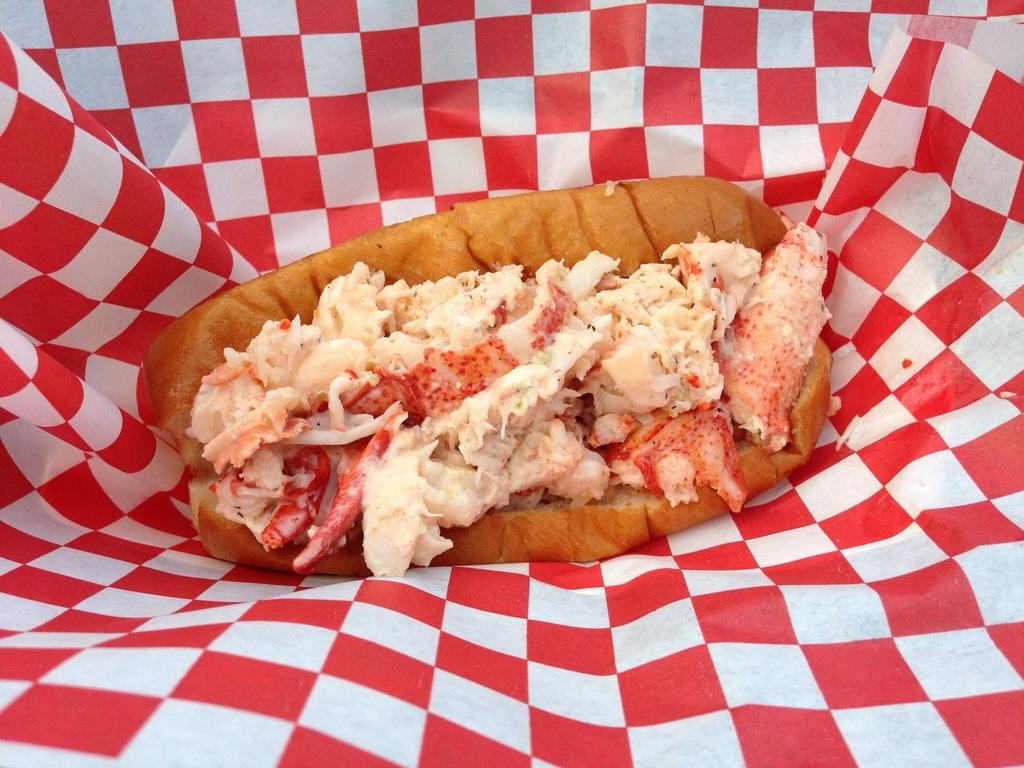What is the main subject of the image? There is a food item in the image. How is the food item wrapped? The food item is wrapped in a red and white paper. What type of chicken can be seen in the image? There is no chicken present in the image; it only features a food item wrapped in red and white paper. What is the needle used for in the image? There is no needle present in the image. 